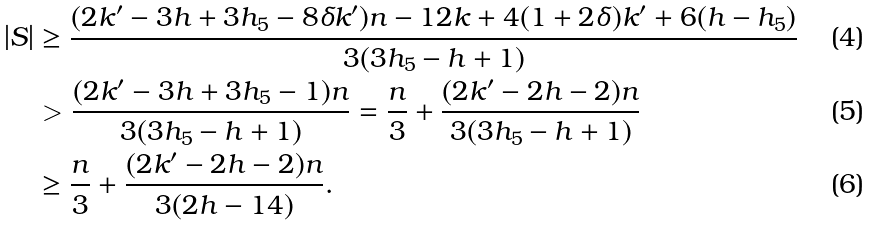Convert formula to latex. <formula><loc_0><loc_0><loc_500><loc_500>| S | & \geq \frac { ( 2 k ^ { \prime } - 3 h + 3 h _ { 5 } - 8 \delta k ^ { \prime } ) n - 1 2 k + 4 ( 1 + 2 \delta ) k ^ { \prime } + 6 ( h - h _ { 5 } ) } { 3 ( 3 h _ { 5 } - h + 1 ) } \\ & > \frac { ( 2 k ^ { \prime } - 3 h + 3 h _ { 5 } - 1 ) n } { 3 ( 3 h _ { 5 } - h + 1 ) } = \frac { n } { 3 } + \frac { ( 2 k ^ { \prime } - 2 h - 2 ) n } { 3 ( 3 h _ { 5 } - h + 1 ) } \\ & \geq \frac { n } { 3 } + \frac { ( 2 k ^ { \prime } - 2 h - 2 ) n } { 3 ( 2 h - 1 4 ) } .</formula> 